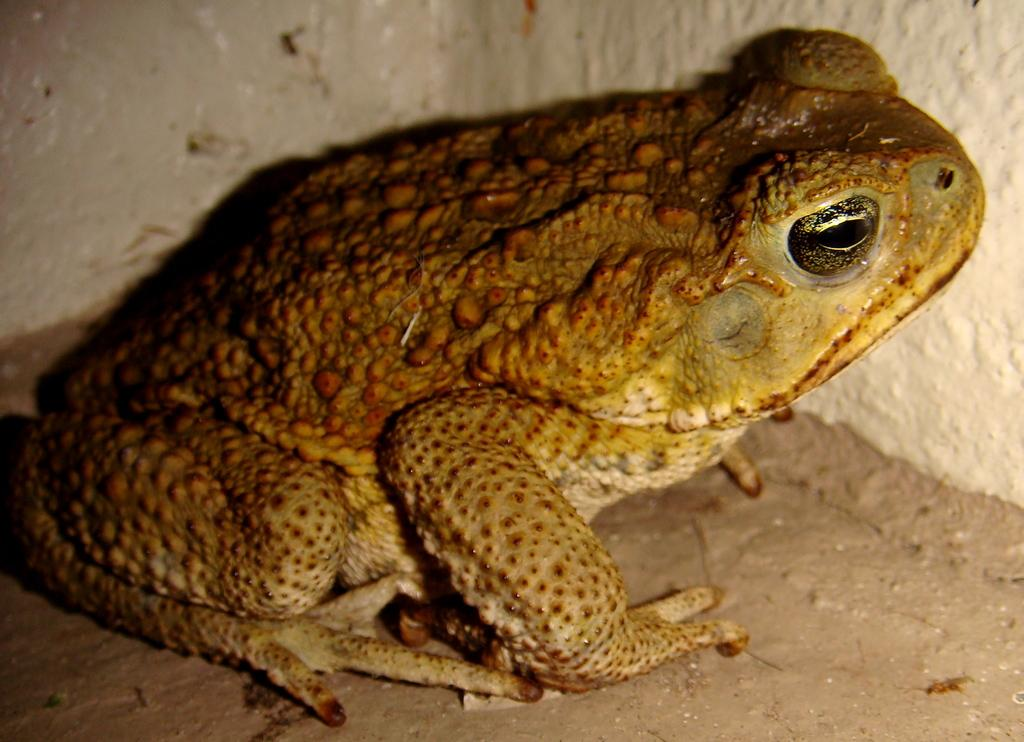What type of animal is in the image? There is a brown color frog in the image. What can be seen in the background of the image? There is a wall in the background of the image. What type of horn can be seen on the frog in the image? There is no horn present on the frog in the image. What does the frog taste like in the image? The image is not a sensory experience, so it is not possible to determine the taste of the frog. 